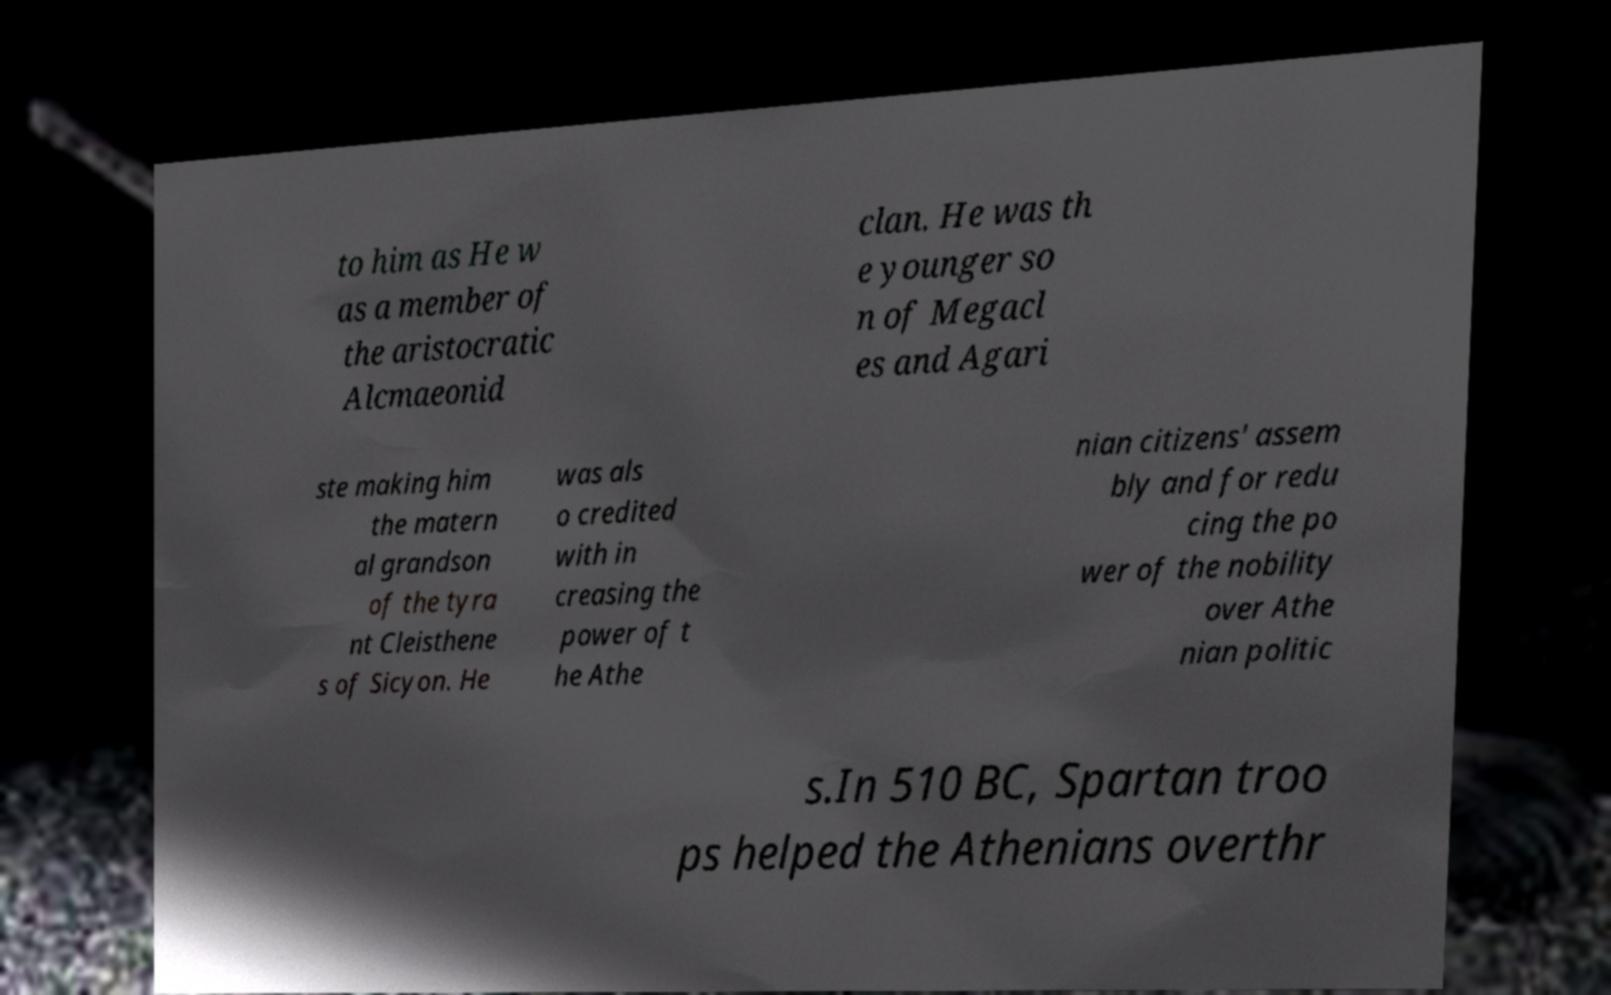Could you extract and type out the text from this image? to him as He w as a member of the aristocratic Alcmaeonid clan. He was th e younger so n of Megacl es and Agari ste making him the matern al grandson of the tyra nt Cleisthene s of Sicyon. He was als o credited with in creasing the power of t he Athe nian citizens' assem bly and for redu cing the po wer of the nobility over Athe nian politic s.In 510 BC, Spartan troo ps helped the Athenians overthr 